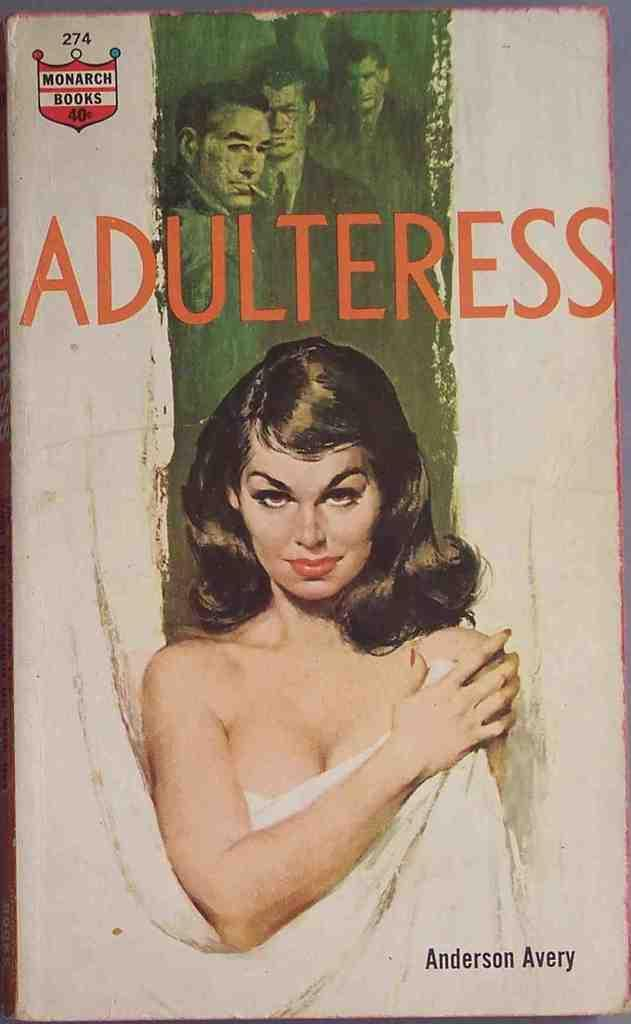What is the main subject of focus of the image? The main focus of the image is a picture of a woman. Are there any other people in the image besides the woman? Yes, there are men standing in the image. Is there any text present in the image? Yes, there is text visible in the image. Can you tell me how many tickets the tiger is holding in the image? There is no tiger present in the image, so it is not possible to determine how many tickets it might be holding. 